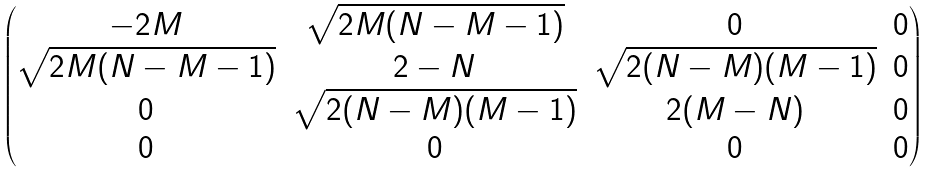Convert formula to latex. <formula><loc_0><loc_0><loc_500><loc_500>\begin{pmatrix} - 2 M & \sqrt { 2 M ( N - M - 1 ) } & 0 & 0 \\ \sqrt { 2 M ( N - M - 1 ) } & 2 - N & \sqrt { 2 ( N - M ) ( M - 1 ) } & 0 \\ 0 & \sqrt { 2 ( N - M ) ( M - 1 ) } & 2 ( M - N ) & 0 \\ 0 & 0 & 0 & 0 \end{pmatrix}</formula> 